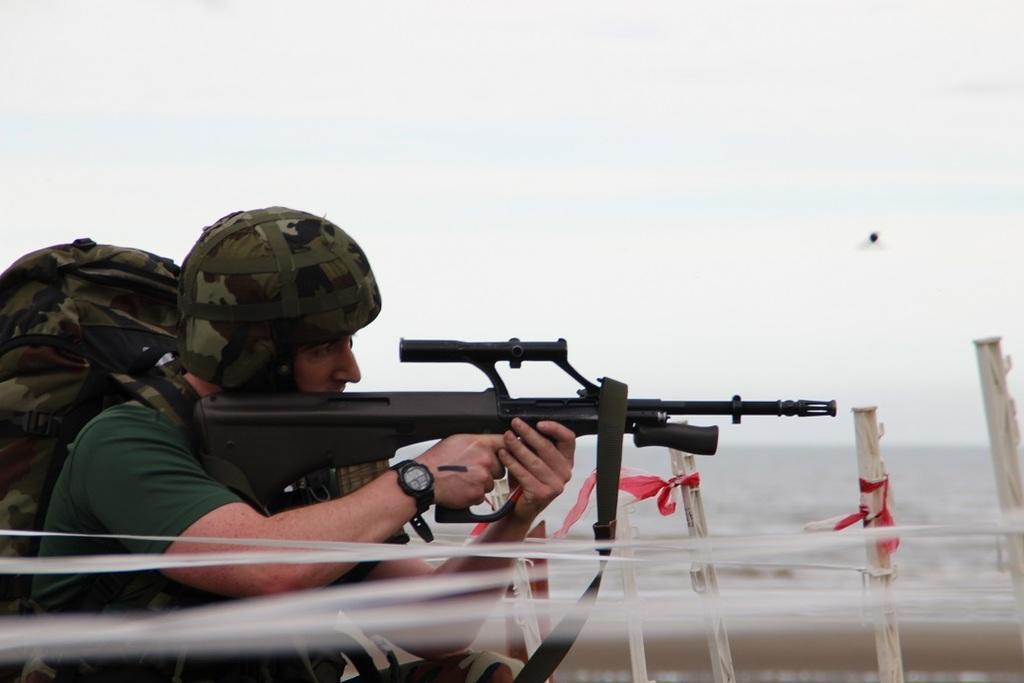How would you summarize this image in a sentence or two? On the left side of the image we can see a man is sitting on his knees and holding a gun and wearing a dress, cap, bag. In the background of the image we can see the barricades. At the top of the image we can see the clouds in the sky. 